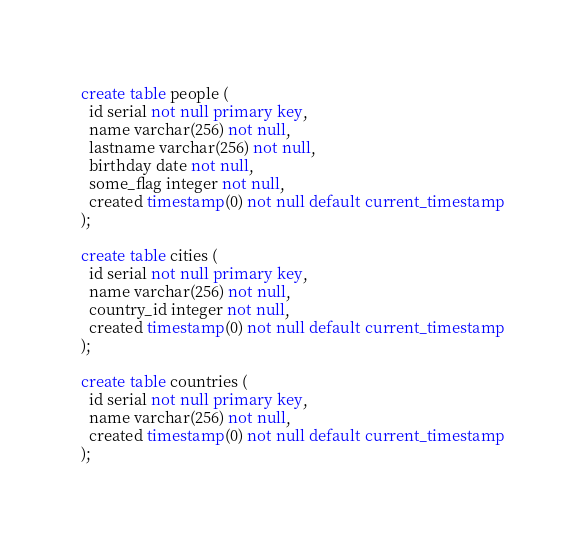Convert code to text. <code><loc_0><loc_0><loc_500><loc_500><_SQL_>create table people (
  id serial not null primary key,
  name varchar(256) not null,
  lastname varchar(256) not null,
  birthday date not null,
  some_flag integer not null,
  created timestamp(0) not null default current_timestamp
);

create table cities (
  id serial not null primary key,
  name varchar(256) not null,
  country_id integer not null,
  created timestamp(0) not null default current_timestamp
);

create table countries (
  id serial not null primary key,
  name varchar(256) not null,
  created timestamp(0) not null default current_timestamp
);
</code> 